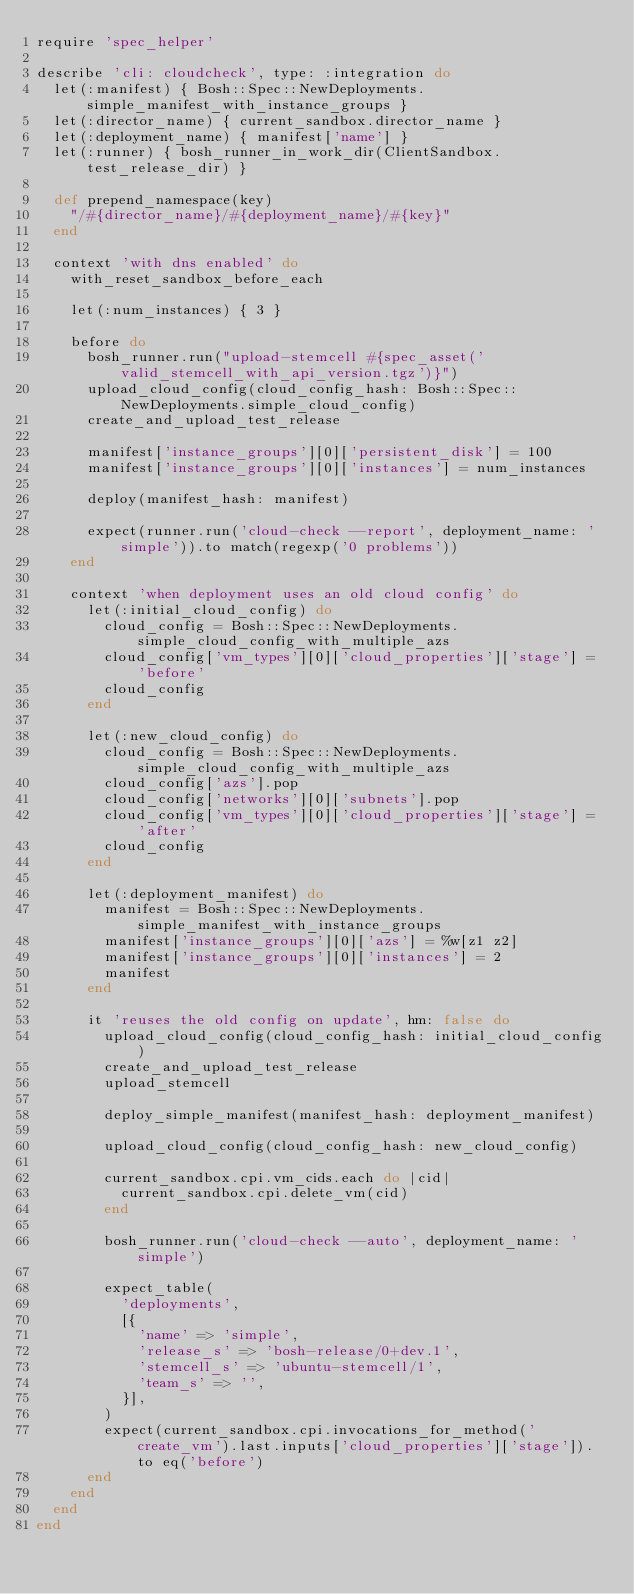<code> <loc_0><loc_0><loc_500><loc_500><_Ruby_>require 'spec_helper'

describe 'cli: cloudcheck', type: :integration do
  let(:manifest) { Bosh::Spec::NewDeployments.simple_manifest_with_instance_groups }
  let(:director_name) { current_sandbox.director_name }
  let(:deployment_name) { manifest['name'] }
  let(:runner) { bosh_runner_in_work_dir(ClientSandbox.test_release_dir) }

  def prepend_namespace(key)
    "/#{director_name}/#{deployment_name}/#{key}"
  end

  context 'with dns enabled' do
    with_reset_sandbox_before_each

    let(:num_instances) { 3 }

    before do
      bosh_runner.run("upload-stemcell #{spec_asset('valid_stemcell_with_api_version.tgz')}")
      upload_cloud_config(cloud_config_hash: Bosh::Spec::NewDeployments.simple_cloud_config)
      create_and_upload_test_release

      manifest['instance_groups'][0]['persistent_disk'] = 100
      manifest['instance_groups'][0]['instances'] = num_instances

      deploy(manifest_hash: manifest)

      expect(runner.run('cloud-check --report', deployment_name: 'simple')).to match(regexp('0 problems'))
    end

    context 'when deployment uses an old cloud config' do
      let(:initial_cloud_config) do
        cloud_config = Bosh::Spec::NewDeployments.simple_cloud_config_with_multiple_azs
        cloud_config['vm_types'][0]['cloud_properties']['stage'] = 'before'
        cloud_config
      end

      let(:new_cloud_config) do
        cloud_config = Bosh::Spec::NewDeployments.simple_cloud_config_with_multiple_azs
        cloud_config['azs'].pop
        cloud_config['networks'][0]['subnets'].pop
        cloud_config['vm_types'][0]['cloud_properties']['stage'] = 'after'
        cloud_config
      end

      let(:deployment_manifest) do
        manifest = Bosh::Spec::NewDeployments.simple_manifest_with_instance_groups
        manifest['instance_groups'][0]['azs'] = %w[z1 z2]
        manifest['instance_groups'][0]['instances'] = 2
        manifest
      end

      it 'reuses the old config on update', hm: false do
        upload_cloud_config(cloud_config_hash: initial_cloud_config)
        create_and_upload_test_release
        upload_stemcell

        deploy_simple_manifest(manifest_hash: deployment_manifest)

        upload_cloud_config(cloud_config_hash: new_cloud_config)

        current_sandbox.cpi.vm_cids.each do |cid|
          current_sandbox.cpi.delete_vm(cid)
        end

        bosh_runner.run('cloud-check --auto', deployment_name: 'simple')

        expect_table(
          'deployments',
          [{
            'name' => 'simple',
            'release_s' => 'bosh-release/0+dev.1',
            'stemcell_s' => 'ubuntu-stemcell/1',
            'team_s' => '',
          }],
        )
        expect(current_sandbox.cpi.invocations_for_method('create_vm').last.inputs['cloud_properties']['stage']).to eq('before')
      end
    end
  end
end
</code> 